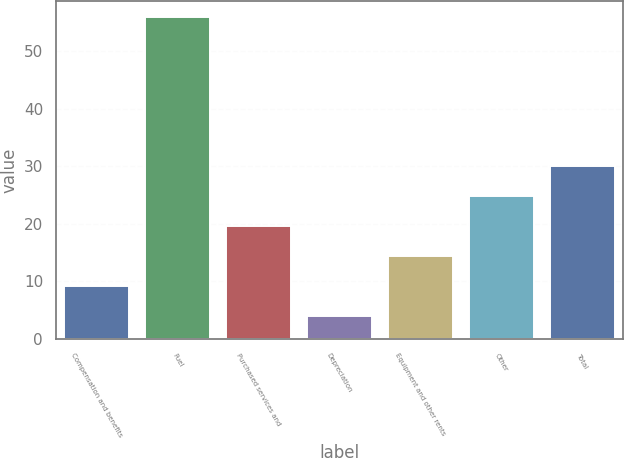<chart> <loc_0><loc_0><loc_500><loc_500><bar_chart><fcel>Compensation and benefits<fcel>Fuel<fcel>Purchased services and<fcel>Depreciation<fcel>Equipment and other rents<fcel>Other<fcel>Total<nl><fcel>9.2<fcel>56<fcel>19.6<fcel>4<fcel>14.4<fcel>24.8<fcel>30<nl></chart> 